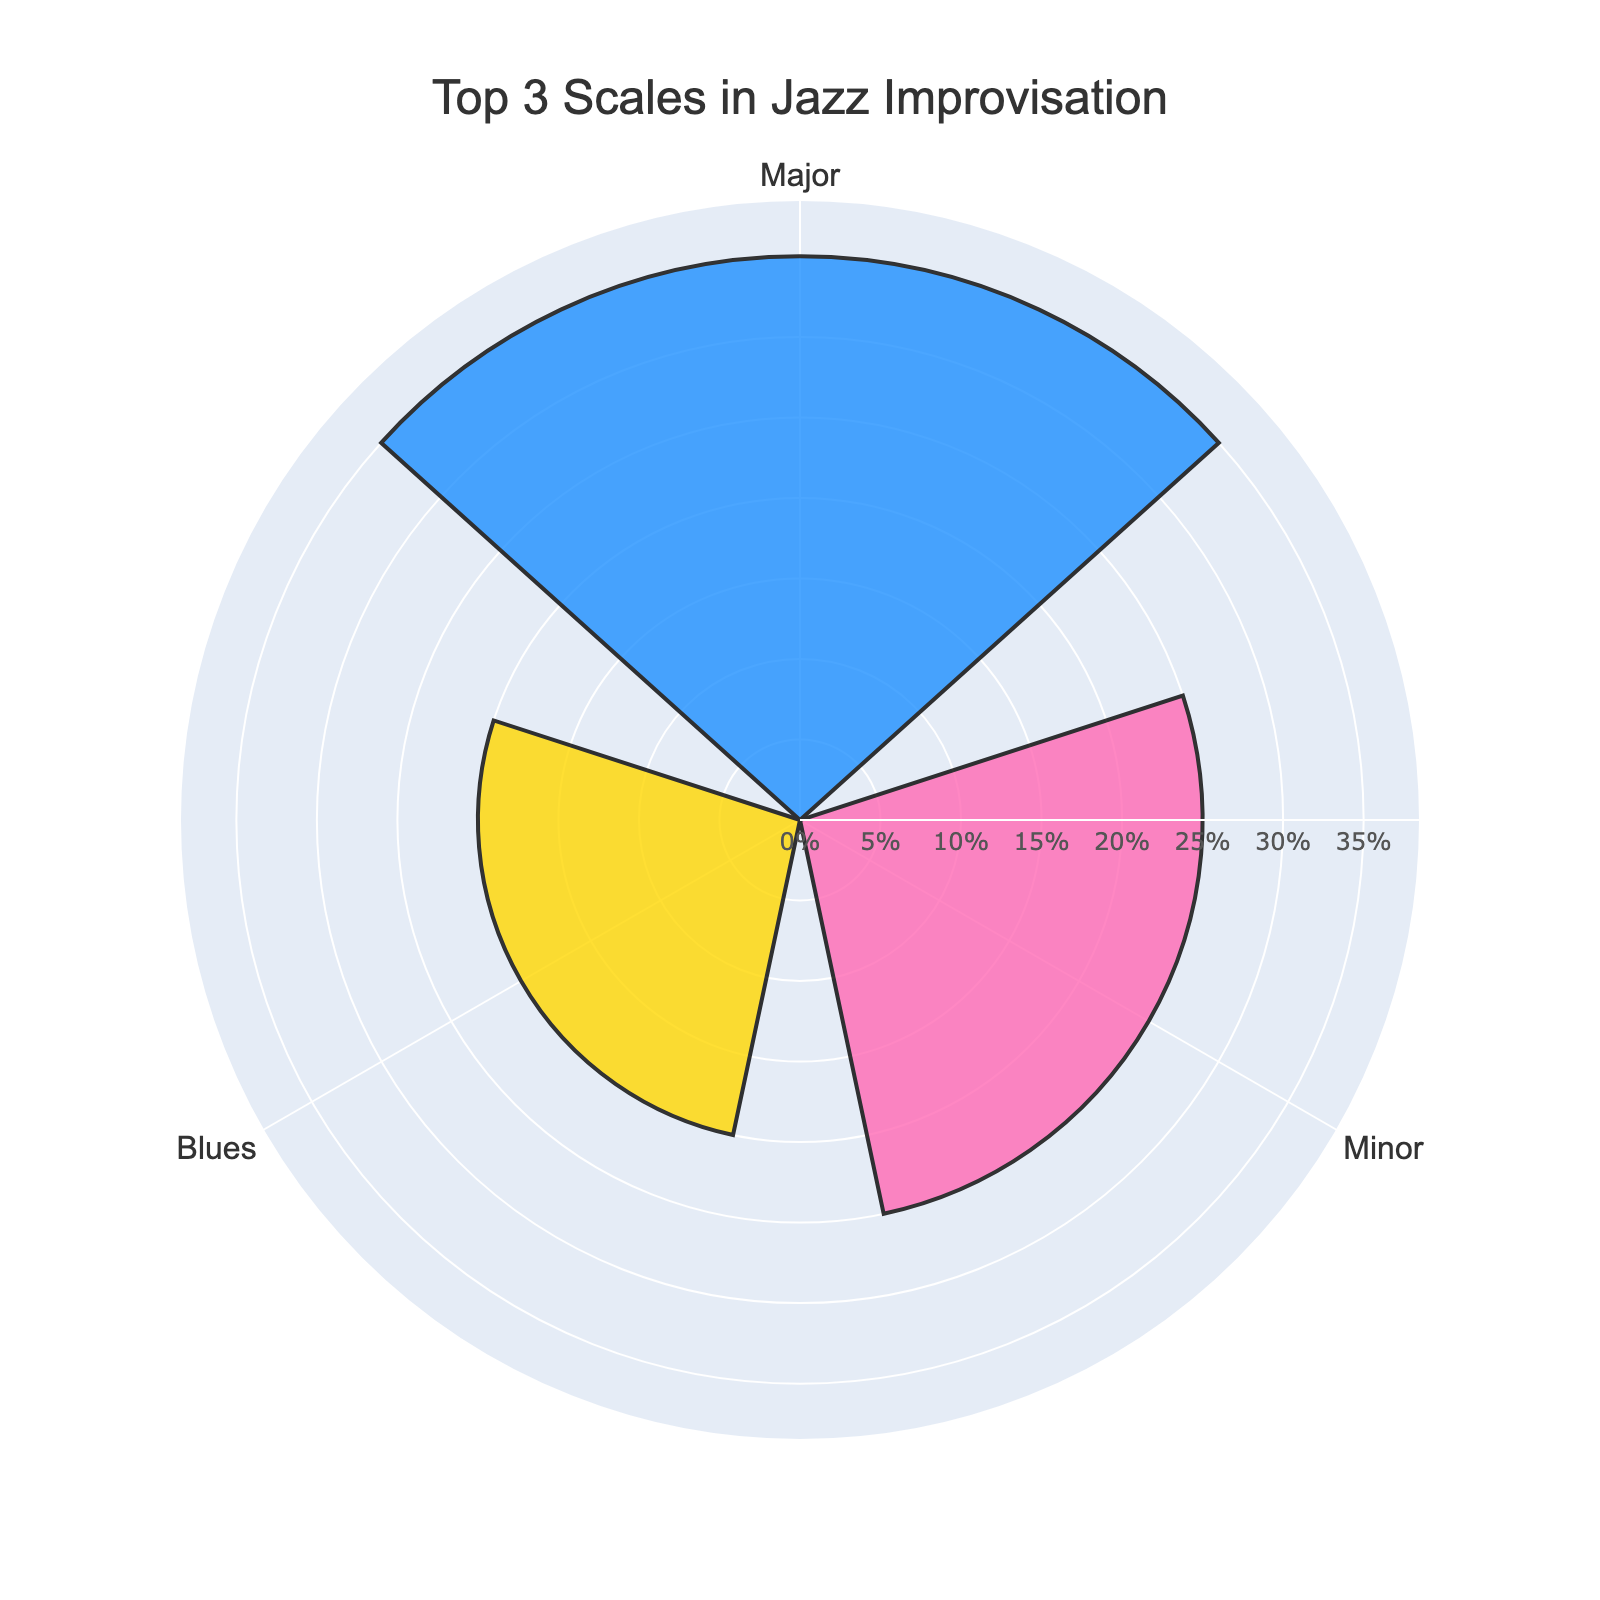What's the title of the figure? The title is prominently displayed at the top of the figure. It is written in a larger font size to draw attention.
Answer: Top 3 Scales in Jazz Improvisation What color represents the Major scale? The colors for each scale are marked distinctly in the figure. The Major scale is represented by the first color.
Answer: Blue What's the combined usage percentage of Major and Minor scales? The usage percentage of the Major scale is 35%, and the Minor scale is 25%. Adding them together gives the total percentage.
Answer: 60% Which scale has the lowest usage percentage among the top 3? Among the three scales shown, the one with the smallest bar length represents the lowest usage percentage.
Answer: Blues How does the usage percentage of the Blues scale compare to the Major scale? The Blues scale has a use percentage of 20%, and the Major scale has 35%. By comparing these two values, we can determine which is smaller.
Answer: Blues scale is less used What's the average usage percentage of the top 3 scales? Sum of the top 3 usage percentages is (35 + 25 + 20) = 80. Dividing by the number of groups (3) gives the average.
Answer: 26.67% What is the purpose of the radial axis labels? The radial axis labels show the usage percentage values to provide a clear indication of how much each scale is used in comparison to the others.
Answer: To show usage percentage In which order are the scales arranged on the figure? The scales are arranged based on the angular positions, starting from the highest percentage to the lowest in a clockwise manner.
Answer: Major, Minor, Blues How much more is the Major scale used than the Blues scale? The usage percentage of Major scale is 35% and Blues scale is 20%. The difference between them is calculated by subtracting the latter from the former.
Answer: 15% Why might the figure use different colors for each scale? Different colors help in distinguishing between the scales quickly and effectively, enhancing visual clarity and comparison.
Answer: To distinguish between scales 